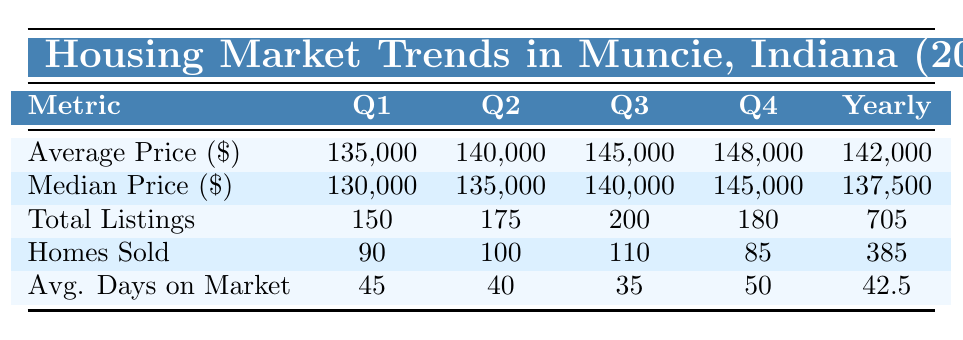What was the average price of homes sold in Q3? The table shows that the average price of homes in Q3 is listed as 145,000.
Answer: 145,000 What is the total number of homes sold throughout the year in 2023? The yearly summary indicates that a total of 385 homes were sold during the year.
Answer: 385 Did the average price increase from Q1 to Q4? Yes, the average price increased from 135,000 in Q1 to 148,000 in Q4.
Answer: Yes What quarter had the highest number of total listings? Q3 had the highest number of total listings with 200.
Answer: Q3 What is the average of the average prices for Q1 and Q2? The average price for Q1 is 135,000 and for Q2 is 140,000. The average is (135,000 + 140,000) / 2 = 137,500.
Answer: 137,500 Which quarter had the fewest homes sold? Q4 showed the fewest homes sold with 85.
Answer: Q4 How many more homes were sold in Q2 compared to Q1? In Q1, 90 homes were sold, and in Q2, 100. The difference is 100 - 90 = 10.
Answer: 10 What was the median price increase from Q1 to Q2? The median price in Q1 was 130,000, and in Q2, it was 135,000. The increase is 135,000 - 130,000 = 5,000.
Answer: 5,000 What is the average number of days on the market across all quarters? The average days on the market are given as 42.5 in the yearly summary.
Answer: 42.5 Did the total listings decrease from Q3 to Q4? Yes, total listings decreased from 200 in Q3 to 180 in Q4.
Answer: Yes Which quarter had the shortest average days on market? Q3 had the shortest average days on the market, with 35 days.
Answer: Q3 How does the median price in Q4 compare to the annual median price? The median price in Q4 is 145,000, while the annual median price is 137,500. Since 145,000 > 137,500, it is higher.
Answer: Higher 